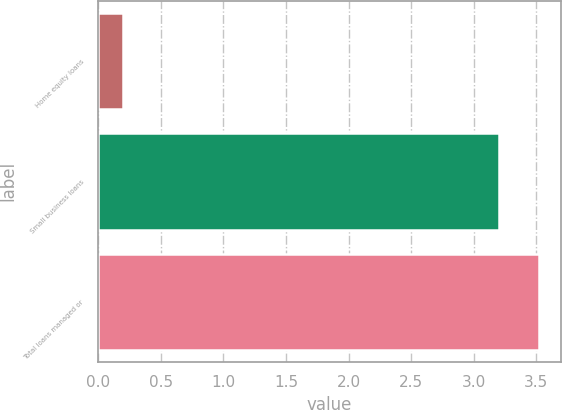Convert chart to OTSL. <chart><loc_0><loc_0><loc_500><loc_500><bar_chart><fcel>Home equity loans<fcel>Small business loans<fcel>Total loans managed or<nl><fcel>0.2<fcel>3.2<fcel>3.52<nl></chart> 